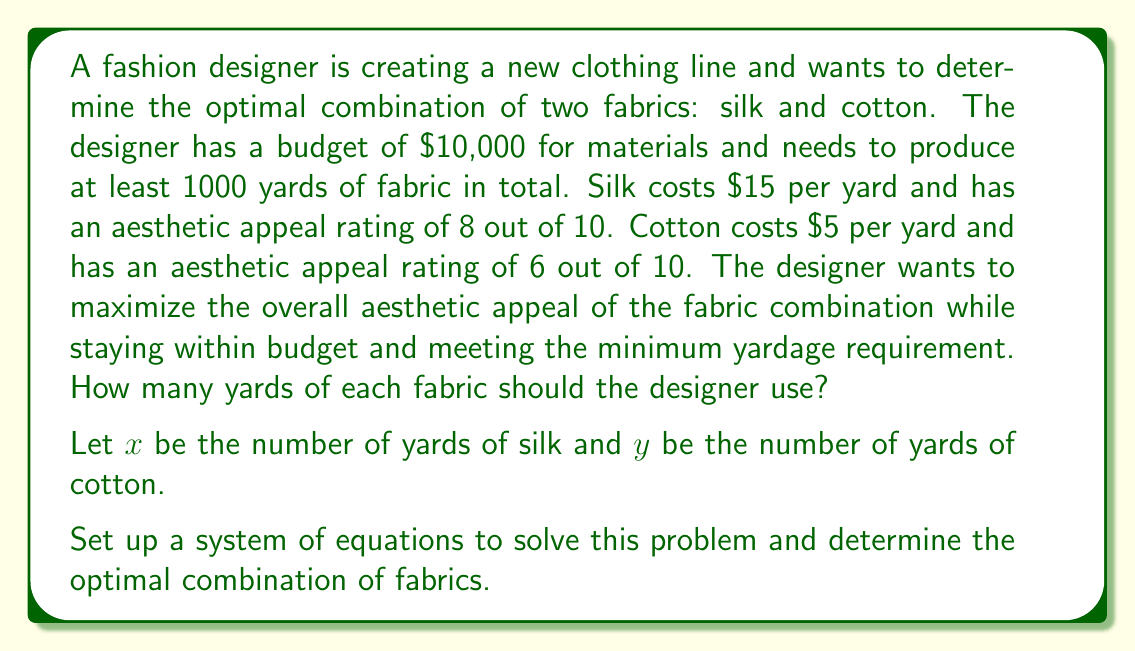Can you solve this math problem? Let's approach this problem step-by-step:

1. First, we need to set up our constraints:

   a) Budget constraint: $15x + 5y \leq 10000$
   b) Minimum yardage constraint: $x + y \geq 1000$
   c) Non-negativity constraints: $x \geq 0$, $y \geq 0$

2. Our objective is to maximize the aesthetic appeal, which can be represented as:
   
   $\text{Maximize } 8x + 6y$

3. To solve this linear programming problem, we can use the corner point method. The feasible region is bounded by the lines:

   $15x + 5y = 10000$ (budget line)
   $x + y = 1000$ (minimum yardage line)

4. Let's find the intersection points:

   a) $(0, 2000)$ - all cotton, but exceeds budget
   b) $(666.67, 333.33)$ - intersection of budget and minimum yardage lines
   c) $(1000, 0)$ - all silk, meets minimum yardage but over budget

5. The only feasible corner point is $(666.67, 333.33)$. Let's round this to whole numbers:
   
   $x = 667$ yards of silk
   $y = 333$ yards of cotton

6. Let's verify the constraints:
   
   Budget: $15(667) + 5(333) = 10005 + 1665 = 11670$ (slightly over budget, we'll adjust)
   Minimum yardage: $667 + 333 = 1000$ (meets requirement)

7. To stay within budget, we need to slightly reduce the silk and increase the cotton:
   
   $x = 666$ yards of silk
   $y = 334$ yards of cotton

8. Final verification:
   
   Budget: $15(666) + 5(334) = 9990 + 1670 = 9660$ (within budget)
   Minimum yardage: $666 + 334 = 1000$ (meets requirement)

9. The aesthetic appeal of this combination is:
   
   $8(666) + 6(334) = 5328 + 2004 = 7332$

This is the maximum aesthetic appeal achievable within the given constraints.
Answer: The optimal combination is 666 yards of silk and 334 yards of cotton. 